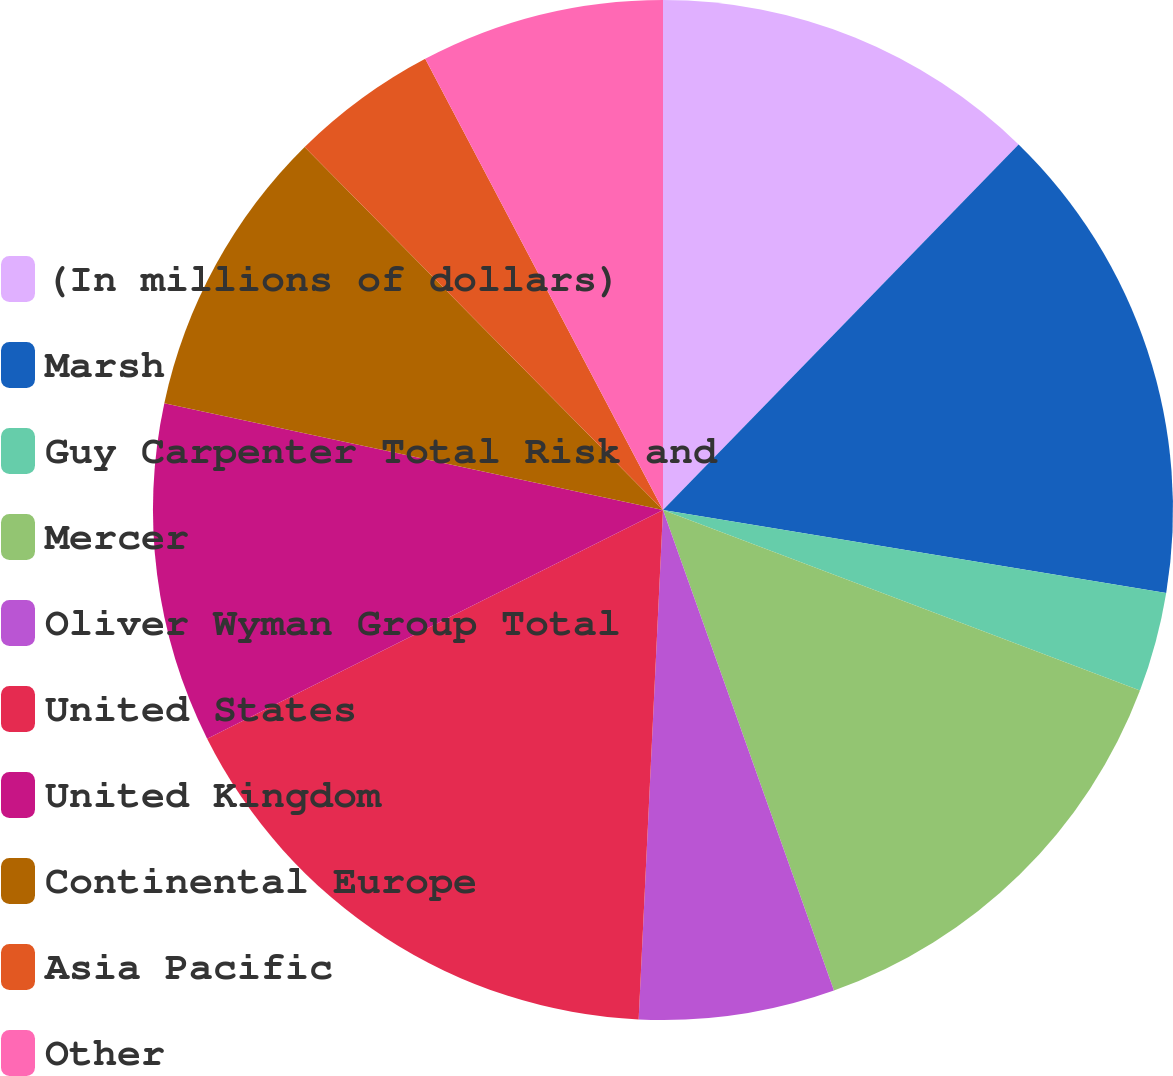<chart> <loc_0><loc_0><loc_500><loc_500><pie_chart><fcel>(In millions of dollars)<fcel>Marsh<fcel>Guy Carpenter Total Risk and<fcel>Mercer<fcel>Oliver Wyman Group Total<fcel>United States<fcel>United Kingdom<fcel>Continental Europe<fcel>Asia Pacific<fcel>Other<nl><fcel>12.28%<fcel>15.32%<fcel>3.16%<fcel>13.8%<fcel>6.2%<fcel>16.84%<fcel>10.76%<fcel>9.24%<fcel>4.68%<fcel>7.72%<nl></chart> 